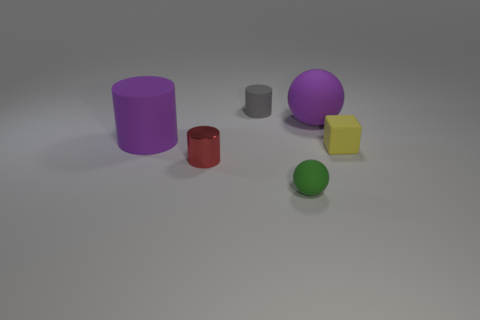There is a object that is both in front of the tiny yellow object and to the right of the tiny metal cylinder; what is its color? green 